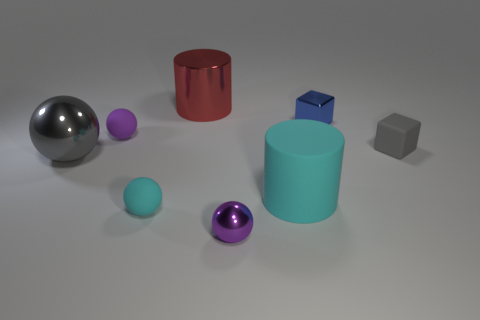There is a sphere that is the same color as the rubber cylinder; what material is it?
Give a very brief answer. Rubber. There is a big cylinder that is made of the same material as the gray ball; what is its color?
Offer a terse response. Red. Does the large cylinder right of the purple metallic thing have the same color as the matte thing in front of the big rubber thing?
Provide a succinct answer. Yes. Are there more small objects to the left of the red cylinder than tiny cyan balls in front of the tiny metal ball?
Make the answer very short. Yes. What color is the other metal thing that is the same shape as the big gray thing?
Provide a short and direct response. Purple. Is there any other thing that has the same shape as the red thing?
Offer a very short reply. Yes. Do the large matte object and the shiny thing left of the red metallic thing have the same shape?
Make the answer very short. No. What number of other objects are there of the same material as the gray block?
Offer a terse response. 3. There is a small matte cube; does it have the same color as the small rubber object that is behind the small gray matte object?
Give a very brief answer. No. What is the purple sphere that is behind the large rubber cylinder made of?
Your answer should be compact. Rubber. 